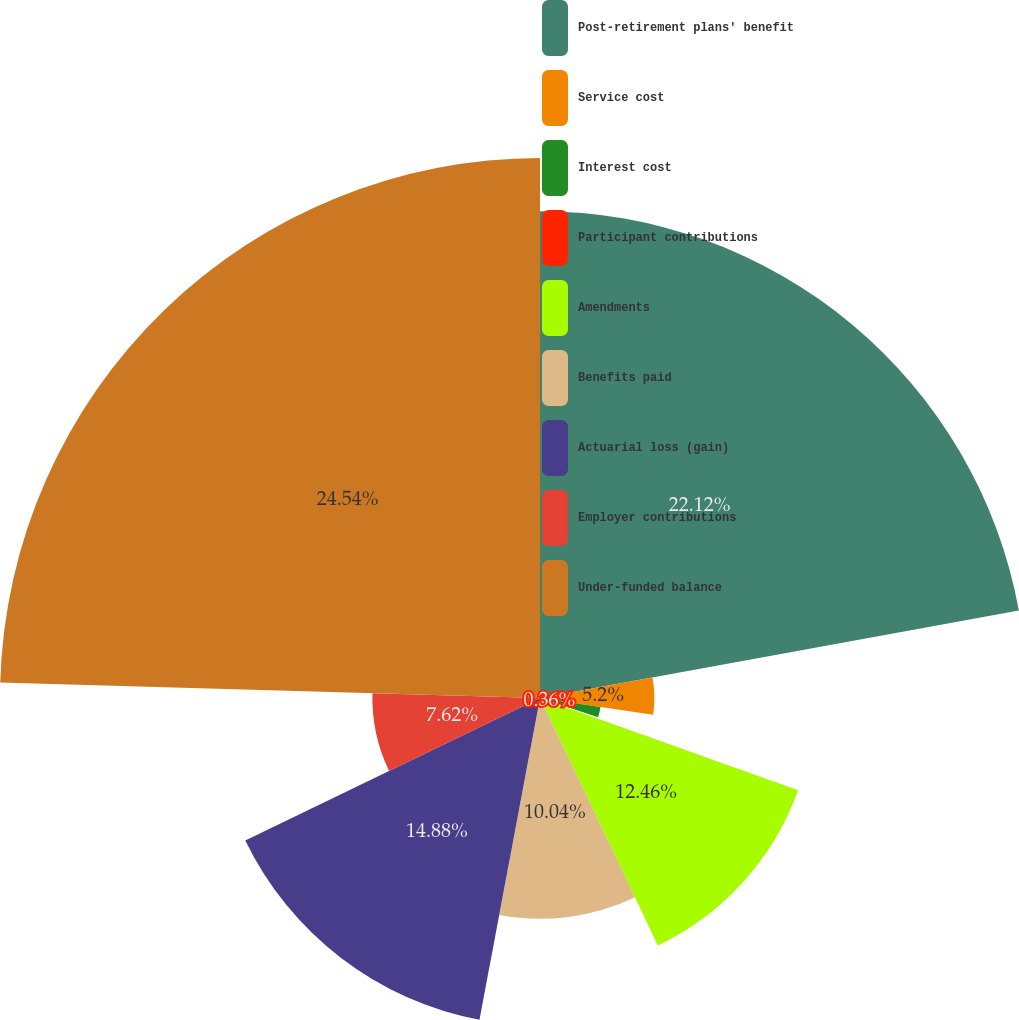Convert chart. <chart><loc_0><loc_0><loc_500><loc_500><pie_chart><fcel>Post-retirement plans' benefit<fcel>Service cost<fcel>Interest cost<fcel>Participant contributions<fcel>Amendments<fcel>Benefits paid<fcel>Actuarial loss (gain)<fcel>Employer contributions<fcel>Under-funded balance<nl><fcel>22.13%<fcel>5.2%<fcel>2.78%<fcel>0.36%<fcel>12.46%<fcel>10.04%<fcel>14.88%<fcel>7.62%<fcel>24.55%<nl></chart> 